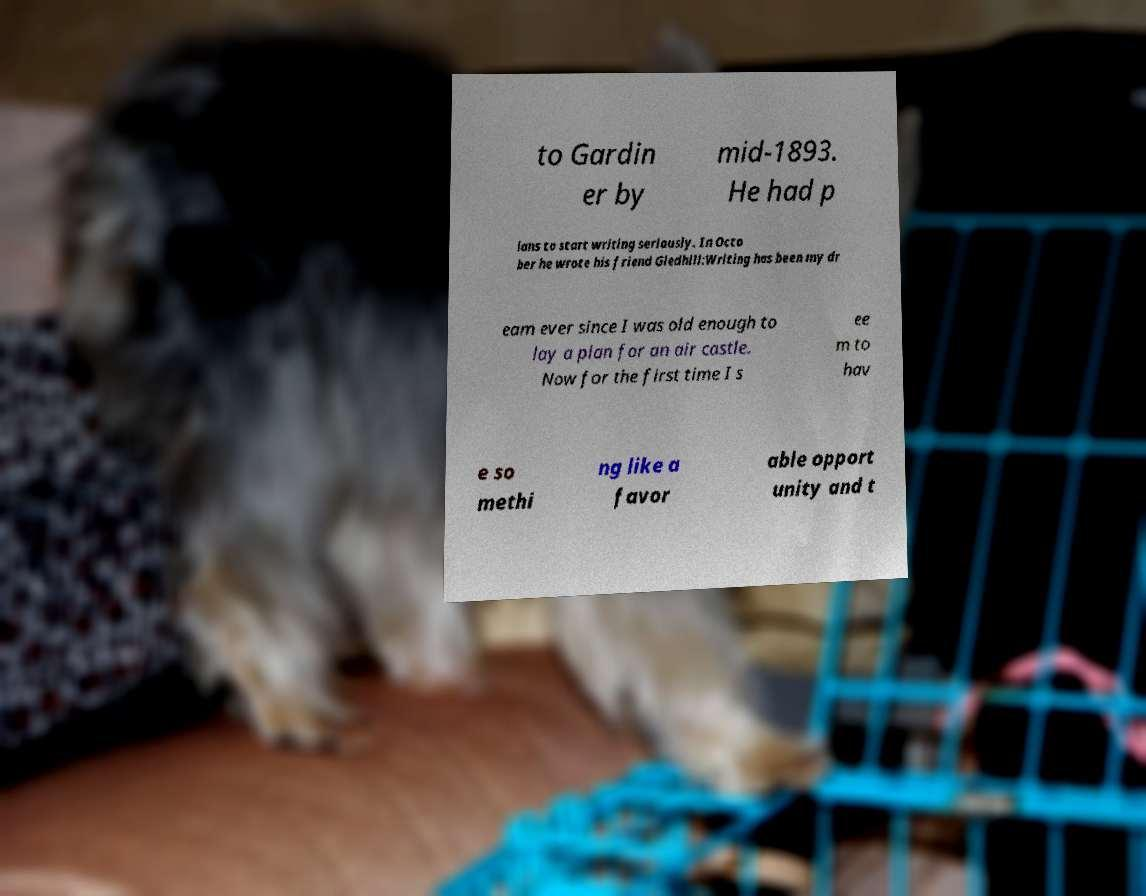Please identify and transcribe the text found in this image. to Gardin er by mid-1893. He had p lans to start writing seriously. In Octo ber he wrote his friend Gledhill:Writing has been my dr eam ever since I was old enough to lay a plan for an air castle. Now for the first time I s ee m to hav e so methi ng like a favor able opport unity and t 